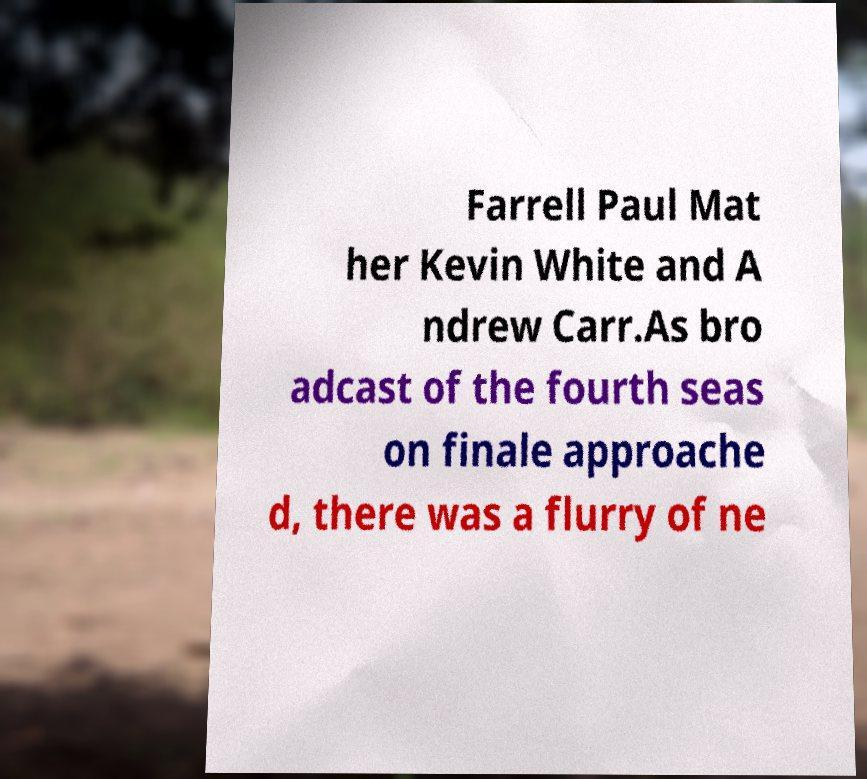There's text embedded in this image that I need extracted. Can you transcribe it verbatim? Farrell Paul Mat her Kevin White and A ndrew Carr.As bro adcast of the fourth seas on finale approache d, there was a flurry of ne 